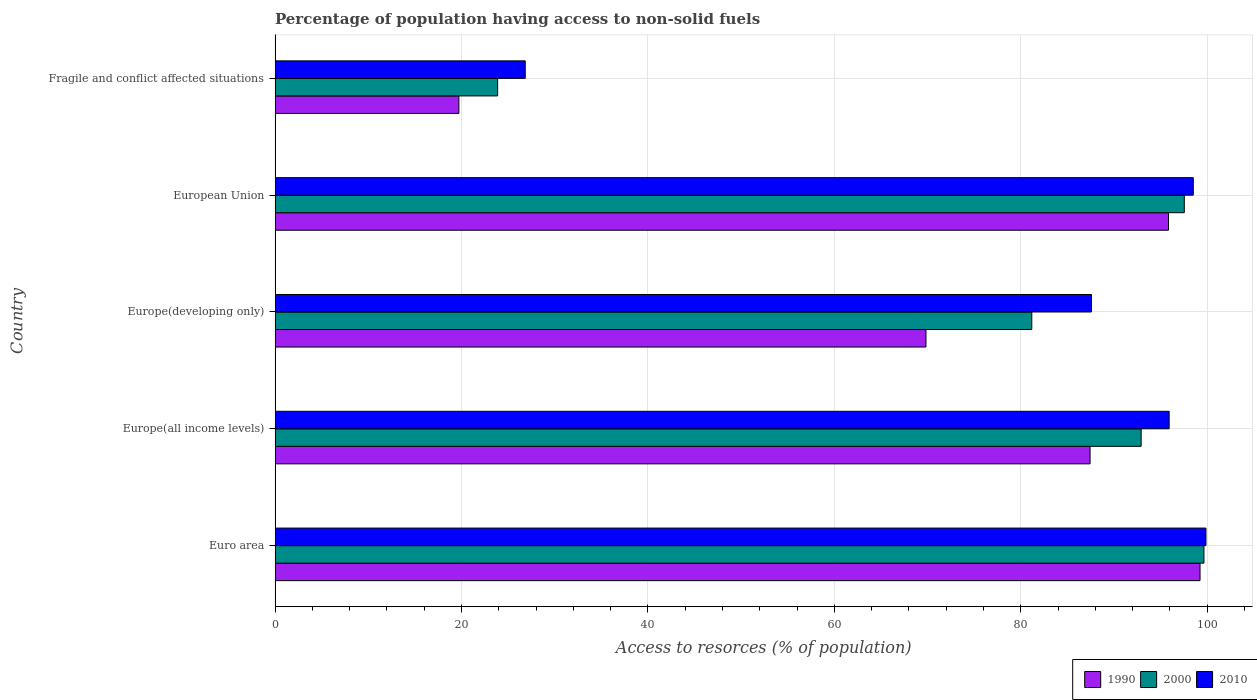How many different coloured bars are there?
Offer a very short reply. 3. How many groups of bars are there?
Provide a short and direct response. 5. Are the number of bars on each tick of the Y-axis equal?
Offer a very short reply. Yes. How many bars are there on the 2nd tick from the top?
Offer a very short reply. 3. What is the label of the 1st group of bars from the top?
Your answer should be very brief. Fragile and conflict affected situations. What is the percentage of population having access to non-solid fuels in 1990 in Europe(developing only)?
Provide a succinct answer. 69.83. Across all countries, what is the maximum percentage of population having access to non-solid fuels in 2000?
Give a very brief answer. 99.66. Across all countries, what is the minimum percentage of population having access to non-solid fuels in 1990?
Provide a succinct answer. 19.72. In which country was the percentage of population having access to non-solid fuels in 2010 minimum?
Your response must be concise. Fragile and conflict affected situations. What is the total percentage of population having access to non-solid fuels in 2000 in the graph?
Ensure brevity in your answer.  395.18. What is the difference between the percentage of population having access to non-solid fuels in 2000 in Europe(all income levels) and that in Europe(developing only)?
Keep it short and to the point. 11.73. What is the difference between the percentage of population having access to non-solid fuels in 2000 in Euro area and the percentage of population having access to non-solid fuels in 2010 in Fragile and conflict affected situations?
Provide a succinct answer. 72.82. What is the average percentage of population having access to non-solid fuels in 2000 per country?
Keep it short and to the point. 79.04. What is the difference between the percentage of population having access to non-solid fuels in 2000 and percentage of population having access to non-solid fuels in 2010 in Europe(all income levels)?
Provide a short and direct response. -3.01. What is the ratio of the percentage of population having access to non-solid fuels in 2000 in European Union to that in Fragile and conflict affected situations?
Provide a short and direct response. 4.09. Is the percentage of population having access to non-solid fuels in 2000 in European Union less than that in Fragile and conflict affected situations?
Keep it short and to the point. No. Is the difference between the percentage of population having access to non-solid fuels in 2000 in Europe(developing only) and European Union greater than the difference between the percentage of population having access to non-solid fuels in 2010 in Europe(developing only) and European Union?
Keep it short and to the point. No. What is the difference between the highest and the second highest percentage of population having access to non-solid fuels in 2010?
Give a very brief answer. 1.36. What is the difference between the highest and the lowest percentage of population having access to non-solid fuels in 2010?
Ensure brevity in your answer.  73.03. In how many countries, is the percentage of population having access to non-solid fuels in 2000 greater than the average percentage of population having access to non-solid fuels in 2000 taken over all countries?
Offer a very short reply. 4. Is the sum of the percentage of population having access to non-solid fuels in 2000 in Euro area and Europe(all income levels) greater than the maximum percentage of population having access to non-solid fuels in 2010 across all countries?
Your answer should be very brief. Yes. What does the 3rd bar from the bottom in Europe(all income levels) represents?
Keep it short and to the point. 2010. How many bars are there?
Your answer should be compact. 15. Are all the bars in the graph horizontal?
Your answer should be very brief. Yes. What is the difference between two consecutive major ticks on the X-axis?
Ensure brevity in your answer.  20. Are the values on the major ticks of X-axis written in scientific E-notation?
Provide a succinct answer. No. Does the graph contain grids?
Provide a short and direct response. Yes. What is the title of the graph?
Provide a succinct answer. Percentage of population having access to non-solid fuels. What is the label or title of the X-axis?
Keep it short and to the point. Access to resorces (% of population). What is the Access to resorces (% of population) in 1990 in Euro area?
Offer a terse response. 99.23. What is the Access to resorces (% of population) in 2000 in Euro area?
Give a very brief answer. 99.66. What is the Access to resorces (% of population) of 2010 in Euro area?
Your answer should be compact. 99.87. What is the Access to resorces (% of population) in 1990 in Europe(all income levels)?
Ensure brevity in your answer.  87.44. What is the Access to resorces (% of population) of 2000 in Europe(all income levels)?
Your answer should be very brief. 92.92. What is the Access to resorces (% of population) of 2010 in Europe(all income levels)?
Provide a short and direct response. 95.92. What is the Access to resorces (% of population) in 1990 in Europe(developing only)?
Make the answer very short. 69.83. What is the Access to resorces (% of population) in 2000 in Europe(developing only)?
Give a very brief answer. 81.18. What is the Access to resorces (% of population) in 2010 in Europe(developing only)?
Provide a succinct answer. 87.59. What is the Access to resorces (% of population) in 1990 in European Union?
Keep it short and to the point. 95.85. What is the Access to resorces (% of population) in 2000 in European Union?
Your answer should be compact. 97.55. What is the Access to resorces (% of population) in 2010 in European Union?
Provide a short and direct response. 98.51. What is the Access to resorces (% of population) in 1990 in Fragile and conflict affected situations?
Offer a terse response. 19.72. What is the Access to resorces (% of population) in 2000 in Fragile and conflict affected situations?
Your answer should be compact. 23.88. What is the Access to resorces (% of population) of 2010 in Fragile and conflict affected situations?
Offer a terse response. 26.84. Across all countries, what is the maximum Access to resorces (% of population) in 1990?
Your answer should be compact. 99.23. Across all countries, what is the maximum Access to resorces (% of population) in 2000?
Give a very brief answer. 99.66. Across all countries, what is the maximum Access to resorces (% of population) of 2010?
Offer a terse response. 99.87. Across all countries, what is the minimum Access to resorces (% of population) of 1990?
Your answer should be compact. 19.72. Across all countries, what is the minimum Access to resorces (% of population) in 2000?
Offer a very short reply. 23.88. Across all countries, what is the minimum Access to resorces (% of population) of 2010?
Offer a terse response. 26.84. What is the total Access to resorces (% of population) of 1990 in the graph?
Ensure brevity in your answer.  372.07. What is the total Access to resorces (% of population) in 2000 in the graph?
Your answer should be compact. 395.18. What is the total Access to resorces (% of population) in 2010 in the graph?
Keep it short and to the point. 408.73. What is the difference between the Access to resorces (% of population) of 1990 in Euro area and that in Europe(all income levels)?
Your answer should be compact. 11.8. What is the difference between the Access to resorces (% of population) in 2000 in Euro area and that in Europe(all income levels)?
Offer a very short reply. 6.74. What is the difference between the Access to resorces (% of population) of 2010 in Euro area and that in Europe(all income levels)?
Your answer should be very brief. 3.95. What is the difference between the Access to resorces (% of population) of 1990 in Euro area and that in Europe(developing only)?
Give a very brief answer. 29.4. What is the difference between the Access to resorces (% of population) of 2000 in Euro area and that in Europe(developing only)?
Your response must be concise. 18.47. What is the difference between the Access to resorces (% of population) of 2010 in Euro area and that in Europe(developing only)?
Keep it short and to the point. 12.28. What is the difference between the Access to resorces (% of population) of 1990 in Euro area and that in European Union?
Keep it short and to the point. 3.38. What is the difference between the Access to resorces (% of population) in 2000 in Euro area and that in European Union?
Your response must be concise. 2.11. What is the difference between the Access to resorces (% of population) in 2010 in Euro area and that in European Union?
Provide a succinct answer. 1.36. What is the difference between the Access to resorces (% of population) in 1990 in Euro area and that in Fragile and conflict affected situations?
Ensure brevity in your answer.  79.51. What is the difference between the Access to resorces (% of population) in 2000 in Euro area and that in Fragile and conflict affected situations?
Make the answer very short. 75.78. What is the difference between the Access to resorces (% of population) of 2010 in Euro area and that in Fragile and conflict affected situations?
Your response must be concise. 73.03. What is the difference between the Access to resorces (% of population) in 1990 in Europe(all income levels) and that in Europe(developing only)?
Offer a very short reply. 17.6. What is the difference between the Access to resorces (% of population) in 2000 in Europe(all income levels) and that in Europe(developing only)?
Offer a terse response. 11.73. What is the difference between the Access to resorces (% of population) in 2010 in Europe(all income levels) and that in Europe(developing only)?
Give a very brief answer. 8.33. What is the difference between the Access to resorces (% of population) in 1990 in Europe(all income levels) and that in European Union?
Keep it short and to the point. -8.42. What is the difference between the Access to resorces (% of population) in 2000 in Europe(all income levels) and that in European Union?
Give a very brief answer. -4.63. What is the difference between the Access to resorces (% of population) in 2010 in Europe(all income levels) and that in European Union?
Provide a short and direct response. -2.59. What is the difference between the Access to resorces (% of population) in 1990 in Europe(all income levels) and that in Fragile and conflict affected situations?
Provide a short and direct response. 67.72. What is the difference between the Access to resorces (% of population) in 2000 in Europe(all income levels) and that in Fragile and conflict affected situations?
Keep it short and to the point. 69.04. What is the difference between the Access to resorces (% of population) of 2010 in Europe(all income levels) and that in Fragile and conflict affected situations?
Your answer should be very brief. 69.08. What is the difference between the Access to resorces (% of population) in 1990 in Europe(developing only) and that in European Union?
Your response must be concise. -26.02. What is the difference between the Access to resorces (% of population) in 2000 in Europe(developing only) and that in European Union?
Your answer should be very brief. -16.36. What is the difference between the Access to resorces (% of population) of 2010 in Europe(developing only) and that in European Union?
Give a very brief answer. -10.92. What is the difference between the Access to resorces (% of population) in 1990 in Europe(developing only) and that in Fragile and conflict affected situations?
Give a very brief answer. 50.11. What is the difference between the Access to resorces (% of population) in 2000 in Europe(developing only) and that in Fragile and conflict affected situations?
Your answer should be compact. 57.31. What is the difference between the Access to resorces (% of population) in 2010 in Europe(developing only) and that in Fragile and conflict affected situations?
Your answer should be compact. 60.75. What is the difference between the Access to resorces (% of population) of 1990 in European Union and that in Fragile and conflict affected situations?
Your answer should be compact. 76.13. What is the difference between the Access to resorces (% of population) of 2000 in European Union and that in Fragile and conflict affected situations?
Provide a succinct answer. 73.67. What is the difference between the Access to resorces (% of population) of 2010 in European Union and that in Fragile and conflict affected situations?
Give a very brief answer. 71.67. What is the difference between the Access to resorces (% of population) of 1990 in Euro area and the Access to resorces (% of population) of 2000 in Europe(all income levels)?
Provide a succinct answer. 6.32. What is the difference between the Access to resorces (% of population) in 1990 in Euro area and the Access to resorces (% of population) in 2010 in Europe(all income levels)?
Your answer should be very brief. 3.31. What is the difference between the Access to resorces (% of population) of 2000 in Euro area and the Access to resorces (% of population) of 2010 in Europe(all income levels)?
Provide a short and direct response. 3.73. What is the difference between the Access to resorces (% of population) in 1990 in Euro area and the Access to resorces (% of population) in 2000 in Europe(developing only)?
Provide a succinct answer. 18.05. What is the difference between the Access to resorces (% of population) in 1990 in Euro area and the Access to resorces (% of population) in 2010 in Europe(developing only)?
Make the answer very short. 11.65. What is the difference between the Access to resorces (% of population) in 2000 in Euro area and the Access to resorces (% of population) in 2010 in Europe(developing only)?
Make the answer very short. 12.07. What is the difference between the Access to resorces (% of population) of 1990 in Euro area and the Access to resorces (% of population) of 2000 in European Union?
Offer a very short reply. 1.69. What is the difference between the Access to resorces (% of population) in 1990 in Euro area and the Access to resorces (% of population) in 2010 in European Union?
Your answer should be very brief. 0.72. What is the difference between the Access to resorces (% of population) in 2000 in Euro area and the Access to resorces (% of population) in 2010 in European Union?
Keep it short and to the point. 1.14. What is the difference between the Access to resorces (% of population) of 1990 in Euro area and the Access to resorces (% of population) of 2000 in Fragile and conflict affected situations?
Give a very brief answer. 75.36. What is the difference between the Access to resorces (% of population) in 1990 in Euro area and the Access to resorces (% of population) in 2010 in Fragile and conflict affected situations?
Ensure brevity in your answer.  72.4. What is the difference between the Access to resorces (% of population) in 2000 in Euro area and the Access to resorces (% of population) in 2010 in Fragile and conflict affected situations?
Ensure brevity in your answer.  72.82. What is the difference between the Access to resorces (% of population) in 1990 in Europe(all income levels) and the Access to resorces (% of population) in 2000 in Europe(developing only)?
Your answer should be very brief. 6.25. What is the difference between the Access to resorces (% of population) in 1990 in Europe(all income levels) and the Access to resorces (% of population) in 2010 in Europe(developing only)?
Make the answer very short. -0.15. What is the difference between the Access to resorces (% of population) of 2000 in Europe(all income levels) and the Access to resorces (% of population) of 2010 in Europe(developing only)?
Offer a terse response. 5.33. What is the difference between the Access to resorces (% of population) of 1990 in Europe(all income levels) and the Access to resorces (% of population) of 2000 in European Union?
Your response must be concise. -10.11. What is the difference between the Access to resorces (% of population) of 1990 in Europe(all income levels) and the Access to resorces (% of population) of 2010 in European Union?
Provide a short and direct response. -11.07. What is the difference between the Access to resorces (% of population) in 2000 in Europe(all income levels) and the Access to resorces (% of population) in 2010 in European Union?
Keep it short and to the point. -5.59. What is the difference between the Access to resorces (% of population) in 1990 in Europe(all income levels) and the Access to resorces (% of population) in 2000 in Fragile and conflict affected situations?
Offer a very short reply. 63.56. What is the difference between the Access to resorces (% of population) of 1990 in Europe(all income levels) and the Access to resorces (% of population) of 2010 in Fragile and conflict affected situations?
Provide a short and direct response. 60.6. What is the difference between the Access to resorces (% of population) of 2000 in Europe(all income levels) and the Access to resorces (% of population) of 2010 in Fragile and conflict affected situations?
Ensure brevity in your answer.  66.08. What is the difference between the Access to resorces (% of population) in 1990 in Europe(developing only) and the Access to resorces (% of population) in 2000 in European Union?
Your answer should be compact. -27.71. What is the difference between the Access to resorces (% of population) of 1990 in Europe(developing only) and the Access to resorces (% of population) of 2010 in European Union?
Your answer should be very brief. -28.68. What is the difference between the Access to resorces (% of population) of 2000 in Europe(developing only) and the Access to resorces (% of population) of 2010 in European Union?
Ensure brevity in your answer.  -17.33. What is the difference between the Access to resorces (% of population) in 1990 in Europe(developing only) and the Access to resorces (% of population) in 2000 in Fragile and conflict affected situations?
Give a very brief answer. 45.95. What is the difference between the Access to resorces (% of population) of 1990 in Europe(developing only) and the Access to resorces (% of population) of 2010 in Fragile and conflict affected situations?
Ensure brevity in your answer.  42.99. What is the difference between the Access to resorces (% of population) in 2000 in Europe(developing only) and the Access to resorces (% of population) in 2010 in Fragile and conflict affected situations?
Keep it short and to the point. 54.35. What is the difference between the Access to resorces (% of population) in 1990 in European Union and the Access to resorces (% of population) in 2000 in Fragile and conflict affected situations?
Keep it short and to the point. 71.98. What is the difference between the Access to resorces (% of population) of 1990 in European Union and the Access to resorces (% of population) of 2010 in Fragile and conflict affected situations?
Provide a short and direct response. 69.02. What is the difference between the Access to resorces (% of population) in 2000 in European Union and the Access to resorces (% of population) in 2010 in Fragile and conflict affected situations?
Offer a terse response. 70.71. What is the average Access to resorces (% of population) of 1990 per country?
Your response must be concise. 74.41. What is the average Access to resorces (% of population) in 2000 per country?
Make the answer very short. 79.04. What is the average Access to resorces (% of population) of 2010 per country?
Provide a succinct answer. 81.75. What is the difference between the Access to resorces (% of population) in 1990 and Access to resorces (% of population) in 2000 in Euro area?
Provide a succinct answer. -0.42. What is the difference between the Access to resorces (% of population) in 1990 and Access to resorces (% of population) in 2010 in Euro area?
Make the answer very short. -0.64. What is the difference between the Access to resorces (% of population) of 2000 and Access to resorces (% of population) of 2010 in Euro area?
Offer a very short reply. -0.21. What is the difference between the Access to resorces (% of population) of 1990 and Access to resorces (% of population) of 2000 in Europe(all income levels)?
Ensure brevity in your answer.  -5.48. What is the difference between the Access to resorces (% of population) in 1990 and Access to resorces (% of population) in 2010 in Europe(all income levels)?
Keep it short and to the point. -8.49. What is the difference between the Access to resorces (% of population) in 2000 and Access to resorces (% of population) in 2010 in Europe(all income levels)?
Provide a succinct answer. -3.01. What is the difference between the Access to resorces (% of population) in 1990 and Access to resorces (% of population) in 2000 in Europe(developing only)?
Make the answer very short. -11.35. What is the difference between the Access to resorces (% of population) in 1990 and Access to resorces (% of population) in 2010 in Europe(developing only)?
Offer a terse response. -17.76. What is the difference between the Access to resorces (% of population) in 2000 and Access to resorces (% of population) in 2010 in Europe(developing only)?
Your answer should be compact. -6.4. What is the difference between the Access to resorces (% of population) in 1990 and Access to resorces (% of population) in 2000 in European Union?
Offer a very short reply. -1.69. What is the difference between the Access to resorces (% of population) in 1990 and Access to resorces (% of population) in 2010 in European Union?
Offer a terse response. -2.66. What is the difference between the Access to resorces (% of population) of 2000 and Access to resorces (% of population) of 2010 in European Union?
Offer a very short reply. -0.96. What is the difference between the Access to resorces (% of population) in 1990 and Access to resorces (% of population) in 2000 in Fragile and conflict affected situations?
Give a very brief answer. -4.16. What is the difference between the Access to resorces (% of population) of 1990 and Access to resorces (% of population) of 2010 in Fragile and conflict affected situations?
Give a very brief answer. -7.12. What is the difference between the Access to resorces (% of population) in 2000 and Access to resorces (% of population) in 2010 in Fragile and conflict affected situations?
Provide a succinct answer. -2.96. What is the ratio of the Access to resorces (% of population) in 1990 in Euro area to that in Europe(all income levels)?
Offer a very short reply. 1.13. What is the ratio of the Access to resorces (% of population) of 2000 in Euro area to that in Europe(all income levels)?
Keep it short and to the point. 1.07. What is the ratio of the Access to resorces (% of population) of 2010 in Euro area to that in Europe(all income levels)?
Provide a succinct answer. 1.04. What is the ratio of the Access to resorces (% of population) of 1990 in Euro area to that in Europe(developing only)?
Your answer should be very brief. 1.42. What is the ratio of the Access to resorces (% of population) of 2000 in Euro area to that in Europe(developing only)?
Your response must be concise. 1.23. What is the ratio of the Access to resorces (% of population) of 2010 in Euro area to that in Europe(developing only)?
Your answer should be compact. 1.14. What is the ratio of the Access to resorces (% of population) in 1990 in Euro area to that in European Union?
Give a very brief answer. 1.04. What is the ratio of the Access to resorces (% of population) in 2000 in Euro area to that in European Union?
Give a very brief answer. 1.02. What is the ratio of the Access to resorces (% of population) of 2010 in Euro area to that in European Union?
Ensure brevity in your answer.  1.01. What is the ratio of the Access to resorces (% of population) in 1990 in Euro area to that in Fragile and conflict affected situations?
Provide a short and direct response. 5.03. What is the ratio of the Access to resorces (% of population) of 2000 in Euro area to that in Fragile and conflict affected situations?
Ensure brevity in your answer.  4.17. What is the ratio of the Access to resorces (% of population) of 2010 in Euro area to that in Fragile and conflict affected situations?
Your answer should be very brief. 3.72. What is the ratio of the Access to resorces (% of population) of 1990 in Europe(all income levels) to that in Europe(developing only)?
Provide a short and direct response. 1.25. What is the ratio of the Access to resorces (% of population) in 2000 in Europe(all income levels) to that in Europe(developing only)?
Make the answer very short. 1.14. What is the ratio of the Access to resorces (% of population) in 2010 in Europe(all income levels) to that in Europe(developing only)?
Your response must be concise. 1.1. What is the ratio of the Access to resorces (% of population) in 1990 in Europe(all income levels) to that in European Union?
Your answer should be compact. 0.91. What is the ratio of the Access to resorces (% of population) in 2000 in Europe(all income levels) to that in European Union?
Keep it short and to the point. 0.95. What is the ratio of the Access to resorces (% of population) in 2010 in Europe(all income levels) to that in European Union?
Provide a succinct answer. 0.97. What is the ratio of the Access to resorces (% of population) of 1990 in Europe(all income levels) to that in Fragile and conflict affected situations?
Make the answer very short. 4.43. What is the ratio of the Access to resorces (% of population) in 2000 in Europe(all income levels) to that in Fragile and conflict affected situations?
Provide a succinct answer. 3.89. What is the ratio of the Access to resorces (% of population) in 2010 in Europe(all income levels) to that in Fragile and conflict affected situations?
Keep it short and to the point. 3.57. What is the ratio of the Access to resorces (% of population) of 1990 in Europe(developing only) to that in European Union?
Provide a succinct answer. 0.73. What is the ratio of the Access to resorces (% of population) in 2000 in Europe(developing only) to that in European Union?
Keep it short and to the point. 0.83. What is the ratio of the Access to resorces (% of population) in 2010 in Europe(developing only) to that in European Union?
Your response must be concise. 0.89. What is the ratio of the Access to resorces (% of population) of 1990 in Europe(developing only) to that in Fragile and conflict affected situations?
Your answer should be compact. 3.54. What is the ratio of the Access to resorces (% of population) in 2000 in Europe(developing only) to that in Fragile and conflict affected situations?
Your answer should be compact. 3.4. What is the ratio of the Access to resorces (% of population) in 2010 in Europe(developing only) to that in Fragile and conflict affected situations?
Provide a succinct answer. 3.26. What is the ratio of the Access to resorces (% of population) of 1990 in European Union to that in Fragile and conflict affected situations?
Provide a short and direct response. 4.86. What is the ratio of the Access to resorces (% of population) of 2000 in European Union to that in Fragile and conflict affected situations?
Make the answer very short. 4.09. What is the ratio of the Access to resorces (% of population) in 2010 in European Union to that in Fragile and conflict affected situations?
Give a very brief answer. 3.67. What is the difference between the highest and the second highest Access to resorces (% of population) of 1990?
Give a very brief answer. 3.38. What is the difference between the highest and the second highest Access to resorces (% of population) in 2000?
Provide a succinct answer. 2.11. What is the difference between the highest and the second highest Access to resorces (% of population) in 2010?
Give a very brief answer. 1.36. What is the difference between the highest and the lowest Access to resorces (% of population) of 1990?
Your response must be concise. 79.51. What is the difference between the highest and the lowest Access to resorces (% of population) of 2000?
Provide a succinct answer. 75.78. What is the difference between the highest and the lowest Access to resorces (% of population) in 2010?
Your response must be concise. 73.03. 